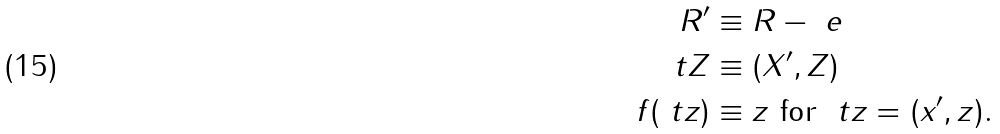<formula> <loc_0><loc_0><loc_500><loc_500>R ^ { \prime } & \equiv R - \ e \\ \ t Z & \equiv ( X ^ { \prime } , Z ) \\ f ( \ t z ) & \equiv z \ \text {for} \ \ t z = ( x ^ { \prime } , z ) .</formula> 